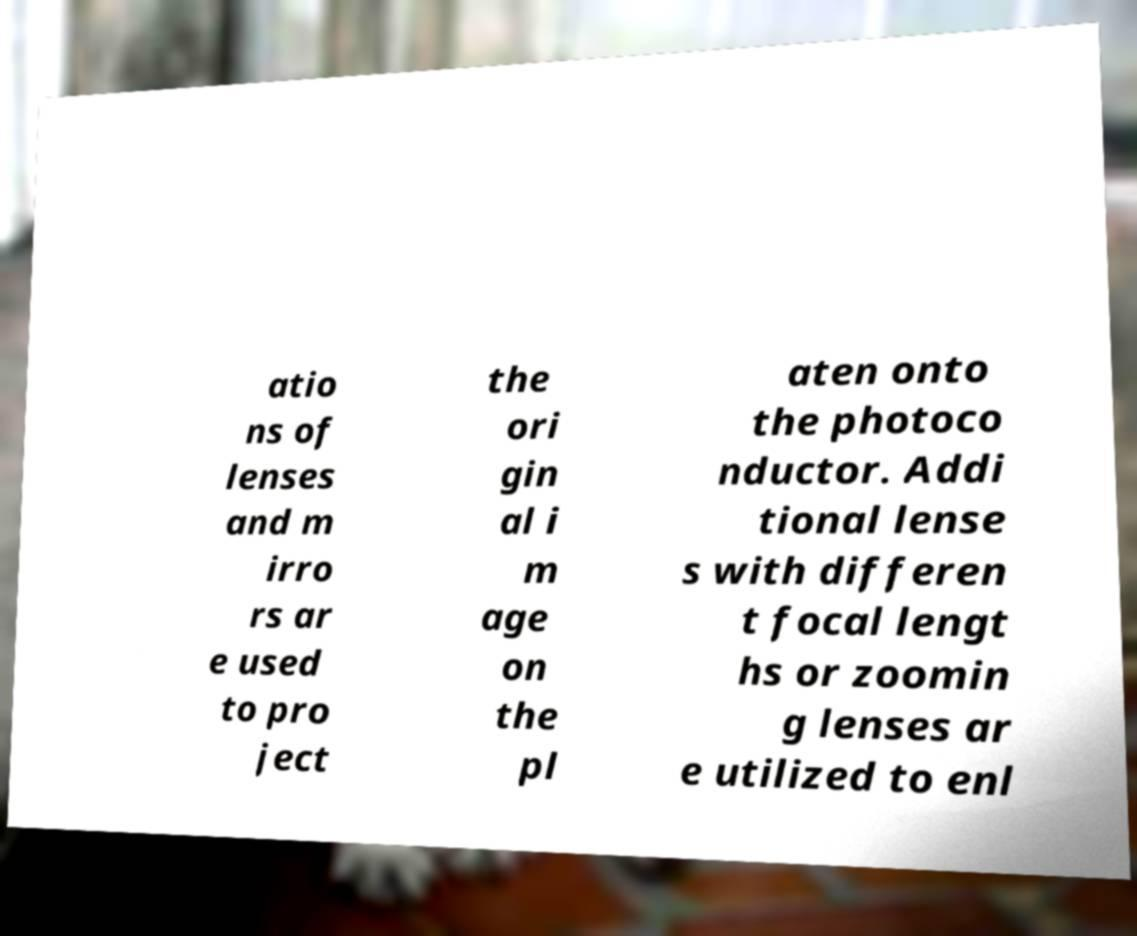Can you read and provide the text displayed in the image?This photo seems to have some interesting text. Can you extract and type it out for me? atio ns of lenses and m irro rs ar e used to pro ject the ori gin al i m age on the pl aten onto the photoco nductor. Addi tional lense s with differen t focal lengt hs or zoomin g lenses ar e utilized to enl 